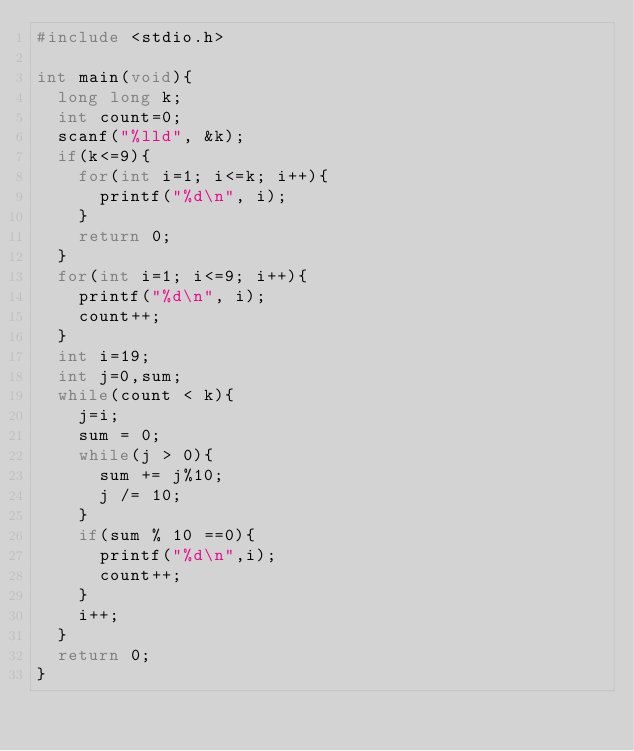<code> <loc_0><loc_0><loc_500><loc_500><_C_>#include <stdio.h>

int main(void){
	long long k;
	int count=0;
	scanf("%lld", &k);
	if(k<=9){
		for(int i=1; i<=k; i++){
			printf("%d\n", i);
		}
		return 0;
	}
	for(int i=1; i<=9; i++){
		printf("%d\n", i);
		count++;
	}
	int i=19;
	int j=0,sum;
	while(count < k){
		j=i;
		sum = 0;
		while(j > 0){
			sum += j%10;
			j /= 10;
		}
		if(sum % 10 ==0){
			printf("%d\n",i);
			count++;
		}	
		i++;
	}
	return 0;
}</code> 